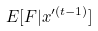<formula> <loc_0><loc_0><loc_500><loc_500>E [ F | x ^ { \prime ( t - 1 ) } ]</formula> 